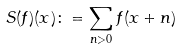Convert formula to latex. <formula><loc_0><loc_0><loc_500><loc_500>S ( f ) ( x ) \colon = \sum _ { n > 0 } f ( x + n )</formula> 